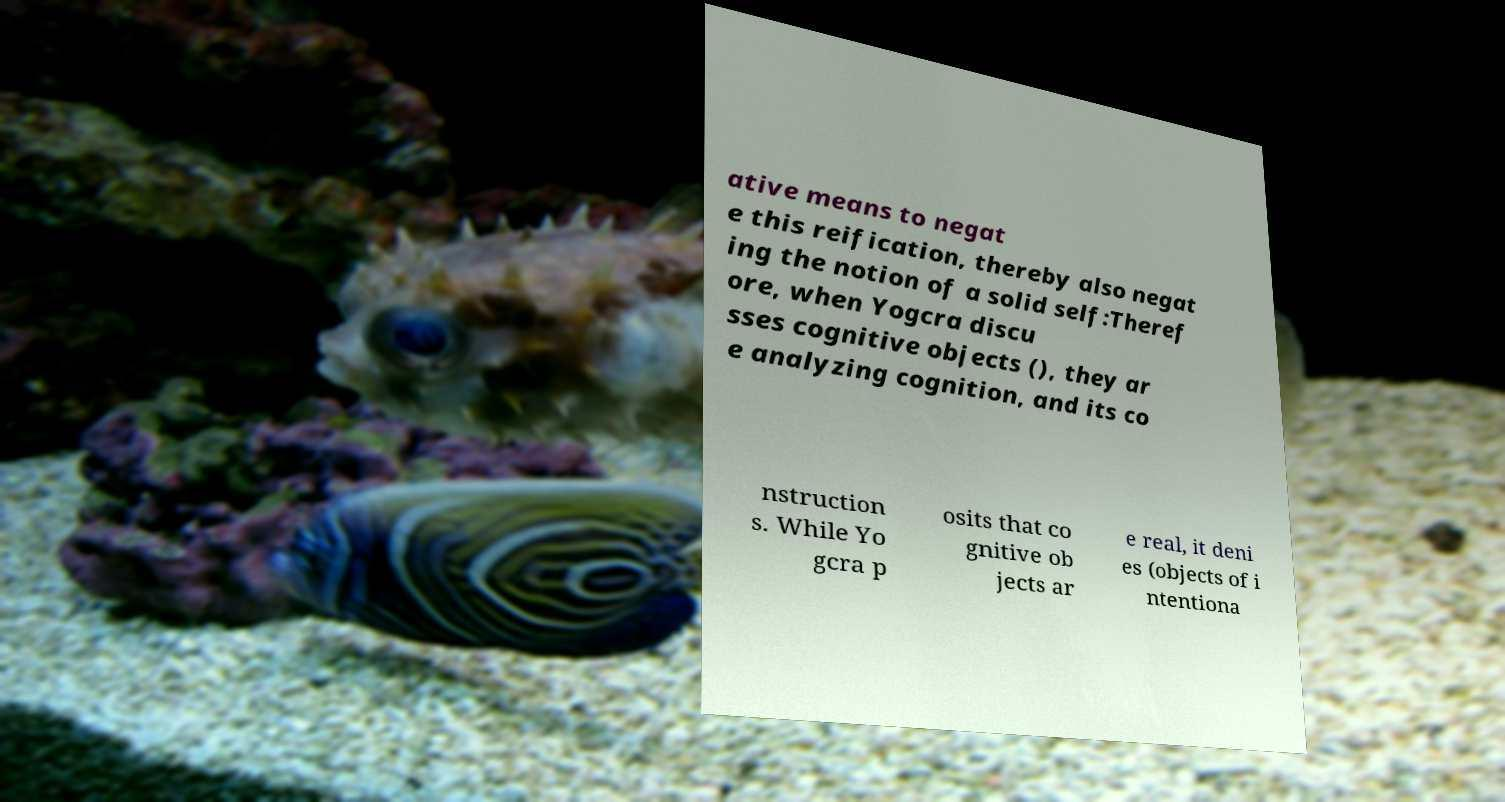There's text embedded in this image that I need extracted. Can you transcribe it verbatim? ative means to negat e this reification, thereby also negat ing the notion of a solid self:Theref ore, when Yogcra discu sses cognitive objects (), they ar e analyzing cognition, and its co nstruction s. While Yo gcra p osits that co gnitive ob jects ar e real, it deni es (objects of i ntentiona 